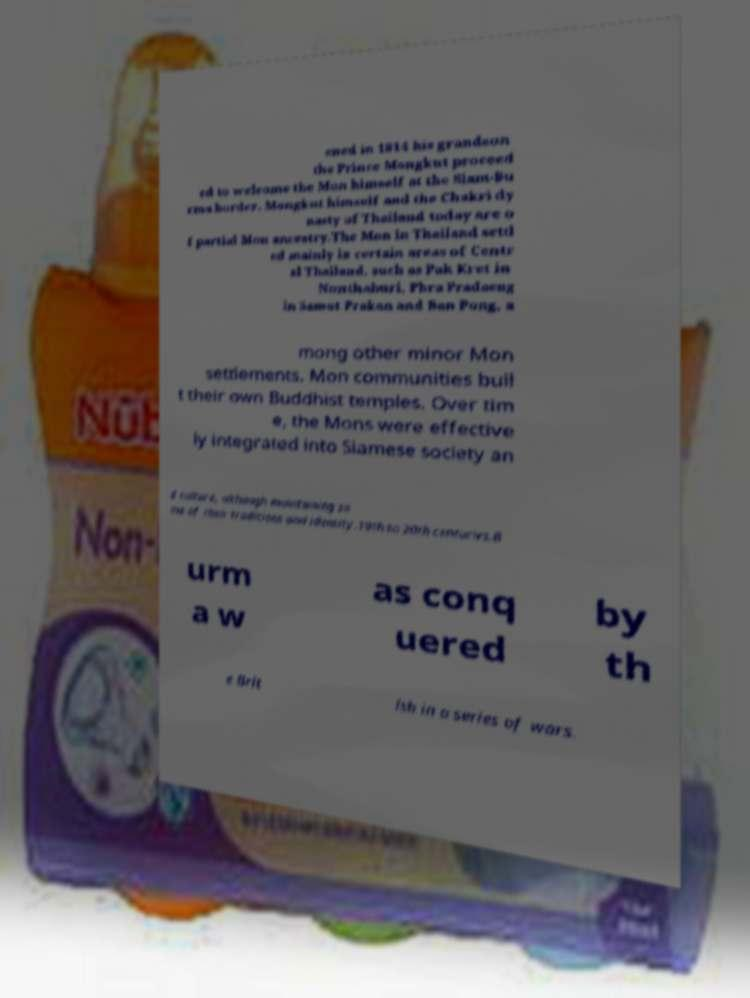Can you read and provide the text displayed in the image?This photo seems to have some interesting text. Can you extract and type it out for me? ened in 1814 his grandson the Prince Mongkut proceed ed to welcome the Mon himself at the Siam-Bu rma border. Mongkut himself and the Chakri dy nasty of Thailand today are o f partial Mon ancestry.The Mon in Thailand settl ed mainly in certain areas of Centr al Thailand, such as Pak Kret in Nonthaburi, Phra Pradaeng in Samut Prakan and Ban Pong, a mong other minor Mon settlements. Mon communities buil t their own Buddhist temples. Over tim e, the Mons were effective ly integrated into Siamese society an d culture, although maintaining so me of their traditions and identity.19th to 20th centuries.B urm a w as conq uered by th e Brit ish in a series of wars. 